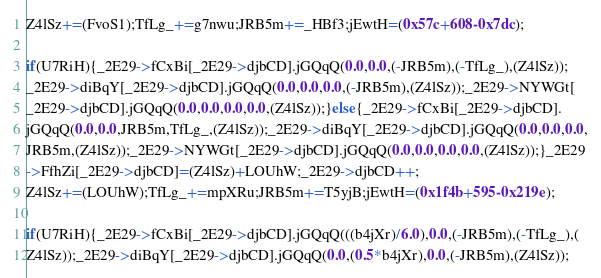<code> <loc_0><loc_0><loc_500><loc_500><_C++_>Z4lSz+=(FvoS1);TfLg_+=g7nwu;JRB5m+=_HBf3;jEwtH=(0x57c+608-0x7dc);

if(U7RiH){_2E29->fCxBi[_2E29->djbCD].jGQqQ(0.0,0.0,(-JRB5m),(-TfLg_),(Z4lSz));
_2E29->diBqY[_2E29->djbCD].jGQqQ(0.0,0.0,0.0,(-JRB5m),(Z4lSz));_2E29->NYWGt[
_2E29->djbCD].jGQqQ(0.0,0.0,0.0,0.0,(Z4lSz));}else{_2E29->fCxBi[_2E29->djbCD].
jGQqQ(0.0,0.0,JRB5m,TfLg_,(Z4lSz));_2E29->diBqY[_2E29->djbCD].jGQqQ(0.0,0.0,0.0,
JRB5m,(Z4lSz));_2E29->NYWGt[_2E29->djbCD].jGQqQ(0.0,0.0,0.0,0.0,(Z4lSz));}_2E29
->FfhZi[_2E29->djbCD]=(Z4lSz)+LOUhW;_2E29->djbCD++;
Z4lSz+=(LOUhW);TfLg_+=mpXRu;JRB5m+=T5yjB;jEwtH=(0x1f4b+595-0x219e);

if(U7RiH){_2E29->fCxBi[_2E29->djbCD].jGQqQ(((b4jXr)/6.0),0.0,(-JRB5m),(-TfLg_),(
Z4lSz));_2E29->diBqY[_2E29->djbCD].jGQqQ(0.0,(0.5*b4jXr),0.0,(-JRB5m),(Z4lSz));</code> 